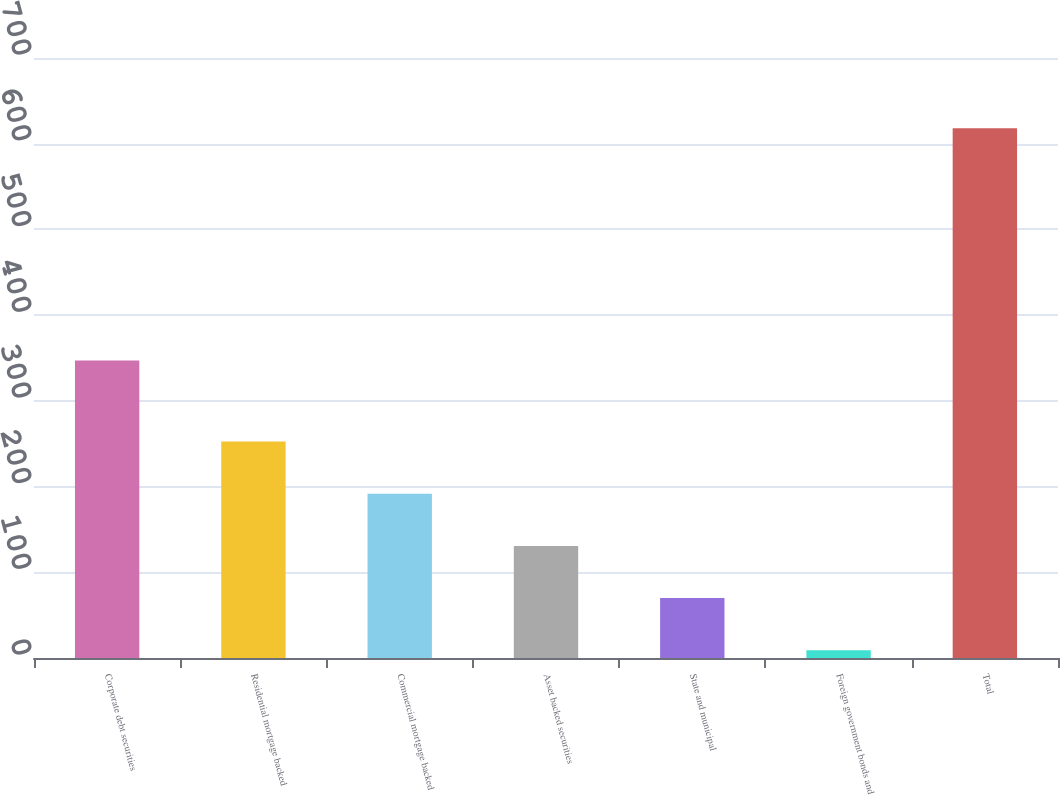Convert chart to OTSL. <chart><loc_0><loc_0><loc_500><loc_500><bar_chart><fcel>Corporate debt securities<fcel>Residential mortgage backed<fcel>Commercial mortgage backed<fcel>Asset backed securities<fcel>State and municipal<fcel>Foreign government bonds and<fcel>Total<nl><fcel>347<fcel>252.6<fcel>191.7<fcel>130.8<fcel>69.9<fcel>9<fcel>618<nl></chart> 